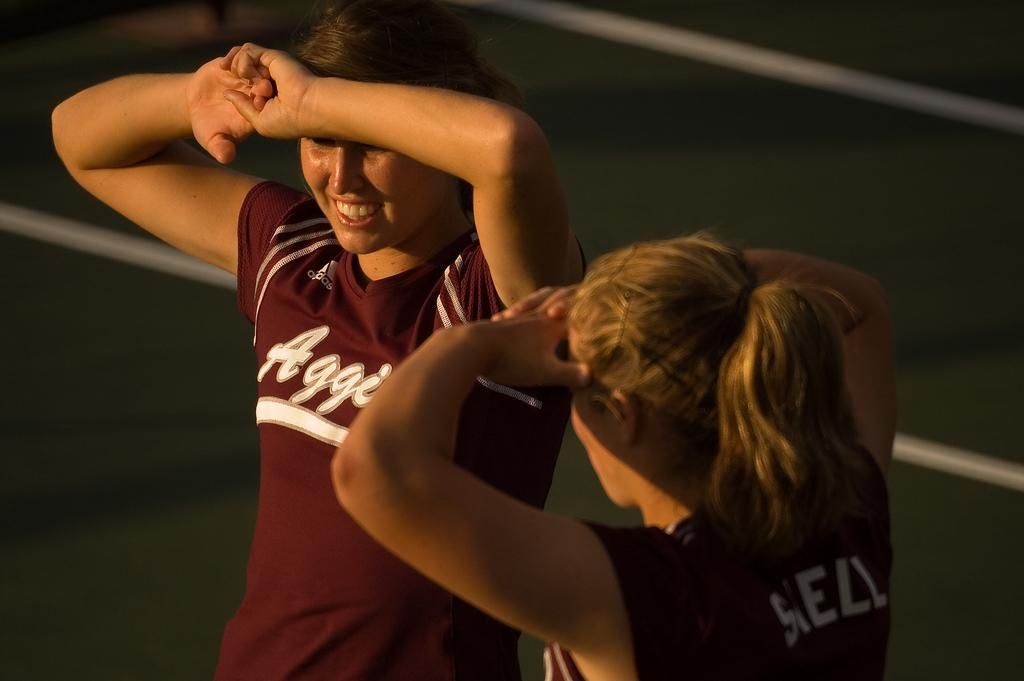Provide a one-sentence caption for the provided image. Two woman wear red sports jerseys for a team starting with "Aggi". 